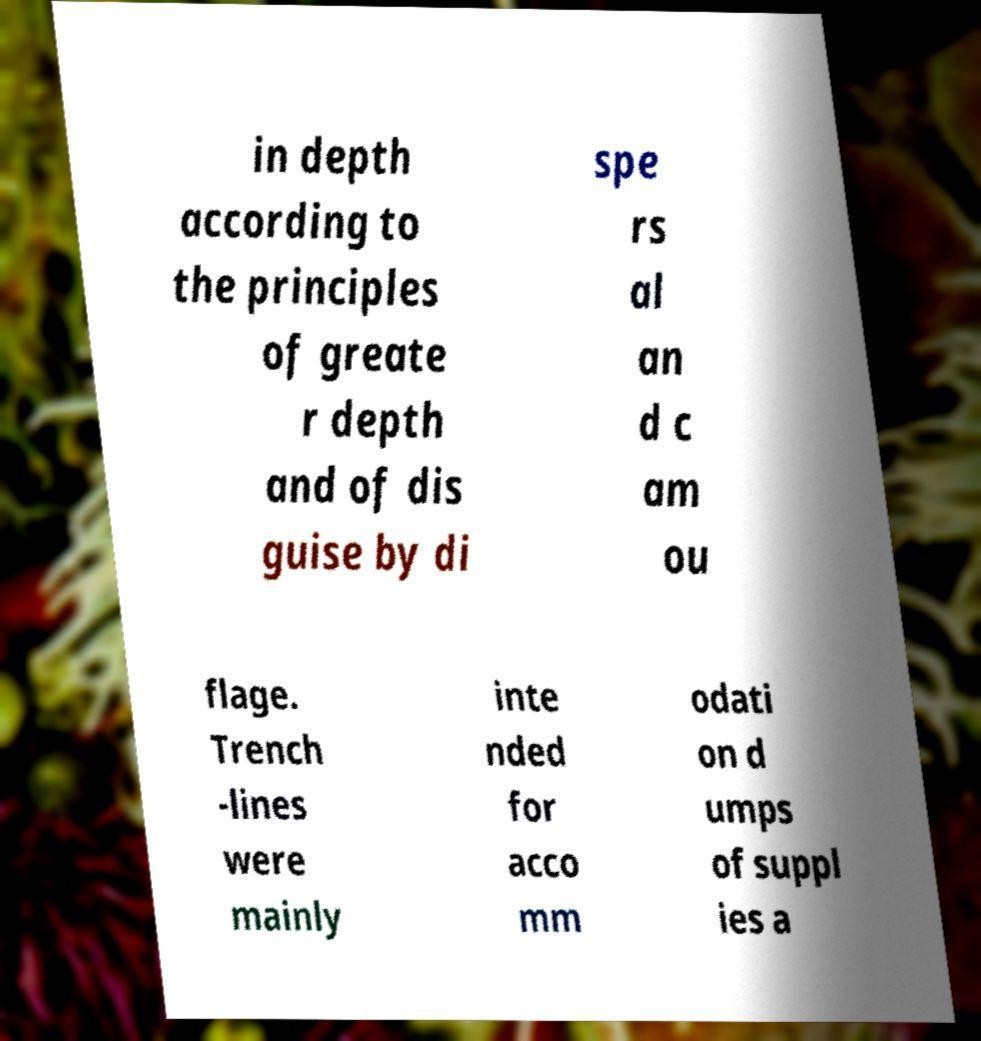Please identify and transcribe the text found in this image. in depth according to the principles of greate r depth and of dis guise by di spe rs al an d c am ou flage. Trench -lines were mainly inte nded for acco mm odati on d umps of suppl ies a 